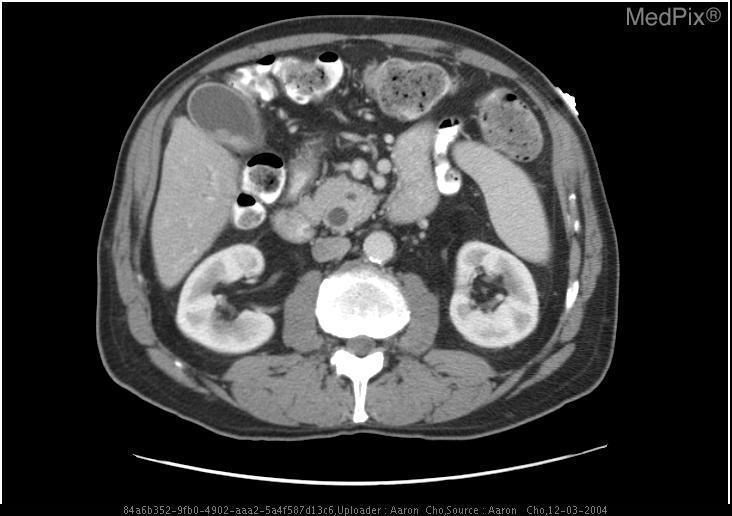Does the gallbladder appear distended?
Give a very brief answer. Yes. Is the gallbladder enlarged?
Answer briefly. Yes. Are the kidneys hyper attenuated?
Give a very brief answer. Yes. Does the pancreatic head appear enlarged?
Quick response, please. Yes. Is the size of the pancreatic head large?
Give a very brief answer. Yes. Are the branches of the superior mesenteric arteries filled with contrast?
Give a very brief answer. Yes. Are the branches of the superior mesenteric arteries hyper attenuated?
Concise answer only. Yes. 